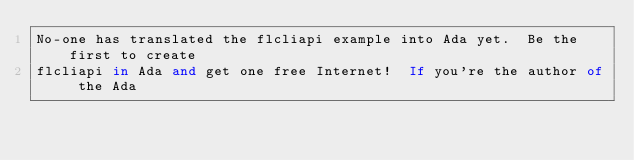<code> <loc_0><loc_0><loc_500><loc_500><_Ada_>No-one has translated the flcliapi example into Ada yet.  Be the first to create
flcliapi in Ada and get one free Internet!  If you're the author of the Ada</code> 